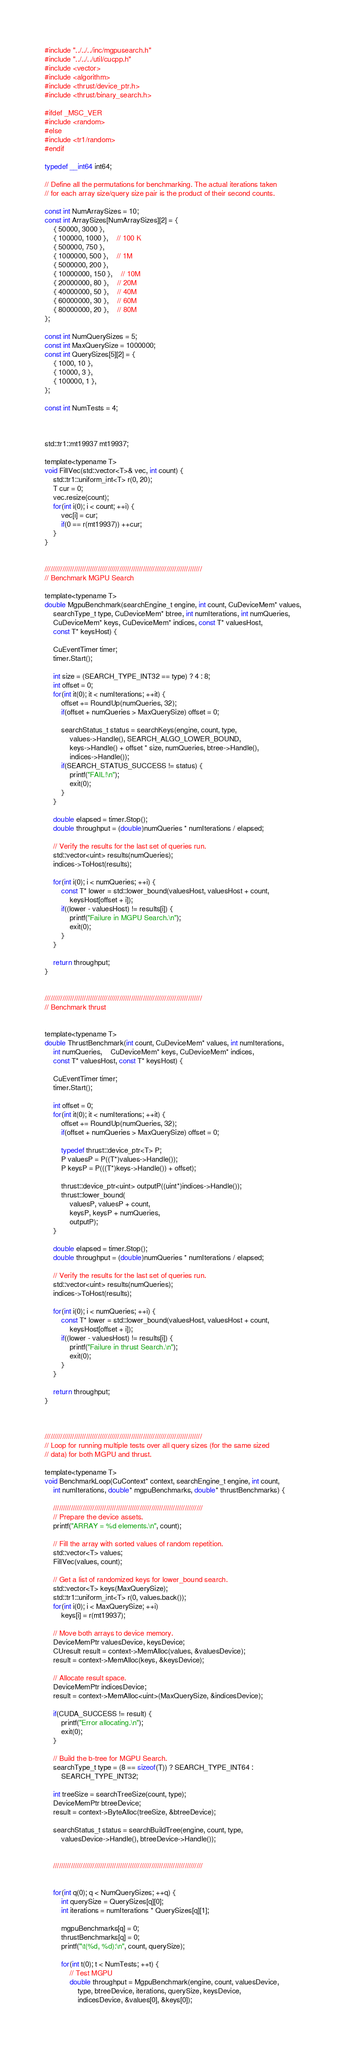Convert code to text. <code><loc_0><loc_0><loc_500><loc_500><_Cuda_>#include "../../../inc/mgpusearch.h"
#include "../../../util/cucpp.h"
#include <vector>
#include <algorithm>
#include <thrust/device_ptr.h>
#include <thrust/binary_search.h>

#ifdef _MSC_VER
#include <random>
#else
#include <tr1/random>
#endif

typedef __int64 int64;

// Define all the permutations for benchmarking. The actual iterations taken
// for each array size/query size pair is the product of their second counts.

const int NumArraySizes = 10;
const int ArraySizes[NumArraySizes][2] = {
	{ 50000, 3000 },		
	{ 100000, 1000 },	// 100 K
	{ 500000, 750 },
	{ 1000000, 500 },	// 1M
	{ 5000000, 200 },
	{ 10000000, 150 },	// 10M
	{ 20000000, 80 },	// 20M
	{ 40000000, 50 },	// 40M
	{ 60000000, 30 },	// 60M
	{ 80000000, 20 },	// 80M
};

const int NumQuerySizes = 5;
const int MaxQuerySize = 1000000;
const int QuerySizes[5][2] = {
	{ 1000, 10 },
	{ 10000, 3 },
	{ 100000, 1 },
};

const int NumTests = 4;


	
std::tr1::mt19937 mt19937;

template<typename T>
void FillVec(std::vector<T>& vec, int count) {
	std::tr1::uniform_int<T> r(0, 20);
	T cur = 0;
	vec.resize(count);
	for(int i(0); i < count; ++i) {
		vec[i] = cur;
		if(0 == r(mt19937)) ++cur;
	}
}


////////////////////////////////////////////////////////////////////////////////
// Benchmark MGPU Search

template<typename T>
double MgpuBenchmark(searchEngine_t engine, int count, CuDeviceMem* values,
	searchType_t type, CuDeviceMem* btree, int numIterations, int numQueries,
	CuDeviceMem* keys, CuDeviceMem* indices, const T* valuesHost,
	const T* keysHost) {

	CuEventTimer timer;
	timer.Start();
	
	int size = (SEARCH_TYPE_INT32 == type) ? 4 : 8;
	int offset = 0;
	for(int it(0); it < numIterations; ++it) {
		offset += RoundUp(numQueries, 32);
		if(offset + numQueries > MaxQuerySize) offset = 0;

		searchStatus_t status = searchKeys(engine, count, type, 
			values->Handle(), SEARCH_ALGO_LOWER_BOUND,
			keys->Handle() + offset * size, numQueries, btree->Handle(),
			indices->Handle());
		if(SEARCH_STATUS_SUCCESS != status) {
			printf("FAIL!\n");
			exit(0);
		}
	}

	double elapsed = timer.Stop();
	double throughput = (double)numQueries * numIterations / elapsed;

	// Verify the results for the last set of queries run.
	std::vector<uint> results(numQueries);
	indices->ToHost(results);

	for(int i(0); i < numQueries; ++i) {
		const T* lower = std::lower_bound(valuesHost, valuesHost + count, 
			keysHost[offset + i]);
		if((lower - valuesHost) != results[i]) {
			printf("Failure in MGPU Search.\n");
			exit(0);
		}
	}

	return throughput;
}


////////////////////////////////////////////////////////////////////////////////
// Benchmark thrust


template<typename T>
double ThrustBenchmark(int count, CuDeviceMem* values, int numIterations,
	int numQueries,	CuDeviceMem* keys, CuDeviceMem* indices, 
	const T* valuesHost, const T* keysHost) {

	CuEventTimer timer;
	timer.Start();

	int offset = 0;
	for(int it(0); it < numIterations; ++it) {
		offset += RoundUp(numQueries, 32);
		if(offset + numQueries > MaxQuerySize) offset = 0;

		typedef thrust::device_ptr<T> P;
		P valuesP = P((T*)values->Handle());
		P keysP = P(((T*)keys->Handle()) + offset);
		
		thrust::device_ptr<uint> outputP((uint*)indices->Handle());
		thrust::lower_bound(
			valuesP, valuesP + count,
			keysP, keysP + numQueries,
			outputP);
	}

	double elapsed = timer.Stop();
	double throughput = (double)numQueries * numIterations / elapsed;

	// Verify the results for the last set of queries run.
	std::vector<uint> results(numQueries);
	indices->ToHost(results);

	for(int i(0); i < numQueries; ++i) {
		const T* lower = std::lower_bound(valuesHost, valuesHost + count, 
			keysHost[offset + i]);
		if((lower - valuesHost) != results[i]) {
			printf("Failure in thrust Search.\n");
			exit(0);
		}
	}

	return throughput;
}



////////////////////////////////////////////////////////////////////////////////
// Loop for running multiple tests over all query sizes (for the same sized
// data) for both MGPU and thrust.

template<typename T>
void BenchmarkLoop(CuContext* context, searchEngine_t engine, int count,
	int numIterations, double* mgpuBenchmarks, double* thrustBenchmarks) {

	////////////////////////////////////////////////////////////////////////////
	// Prepare the device assets.
	printf("ARRAY = %d elements.\n", count);

	// Fill the array with sorted values of random repetition.
	std::vector<T> values;
	FillVec(values, count);

	// Get a list of randomized keys for lower_bound search.
	std::vector<T> keys(MaxQuerySize);
	std::tr1::uniform_int<T> r(0, values.back());
	for(int i(0); i < MaxQuerySize; ++i)
		keys[i] = r(mt19937);

	// Move both arrays to device memory.
	DeviceMemPtr valuesDevice, keysDevice;
	CUresult result = context->MemAlloc(values, &valuesDevice);
	result = context->MemAlloc(keys, &keysDevice);

	// Allocate result space.
	DeviceMemPtr indicesDevice;
	result = context->MemAlloc<uint>(MaxQuerySize, &indicesDevice);

	if(CUDA_SUCCESS != result) {
		printf("Error allocating.\n");
		exit(0);
	}

	// Build the b-tree for MGPU Search.
	searchType_t type = (8 == sizeof(T)) ? SEARCH_TYPE_INT64 : 
		SEARCH_TYPE_INT32;

	int treeSize = searchTreeSize(count, type);
	DeviceMemPtr btreeDevice;
	result = context->ByteAlloc(treeSize, &btreeDevice);

	searchStatus_t status = searchBuildTree(engine, count, type, 
		valuesDevice->Handle(), btreeDevice->Handle());


	////////////////////////////////////////////////////////////////////////////
	

	for(int q(0); q < NumQuerySizes; ++q) {
		int querySize = QuerySizes[q][0];
		int iterations = numIterations * QuerySizes[q][1];

		mgpuBenchmarks[q] = 0;
		thrustBenchmarks[q] = 0;
		printf("\t(%d, %d):\n", count, querySize);

		for(int t(0); t < NumTests; ++t) {
			// Test MGPU
			double throughput = MgpuBenchmark(engine, count, valuesDevice,
				type, btreeDevice, iterations, querySize, keysDevice,
				indicesDevice, &values[0], &keys[0]);</code> 